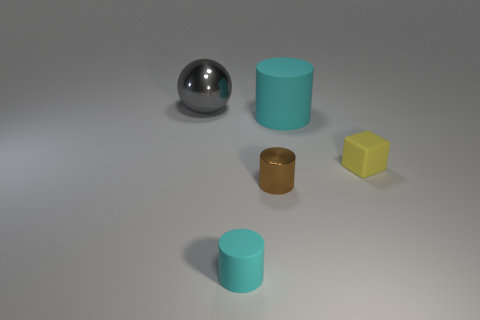Subtract all tiny cyan rubber cylinders. How many cylinders are left? 2 Subtract all purple balls. How many cyan cylinders are left? 2 Subtract 1 cylinders. How many cylinders are left? 2 Add 5 big gray metal things. How many objects exist? 10 Subtract all balls. How many objects are left? 4 Add 1 small cyan objects. How many small cyan objects exist? 2 Subtract 1 cyan cylinders. How many objects are left? 4 Subtract all big cyan rubber cylinders. Subtract all big red matte cylinders. How many objects are left? 4 Add 5 large rubber cylinders. How many large rubber cylinders are left? 6 